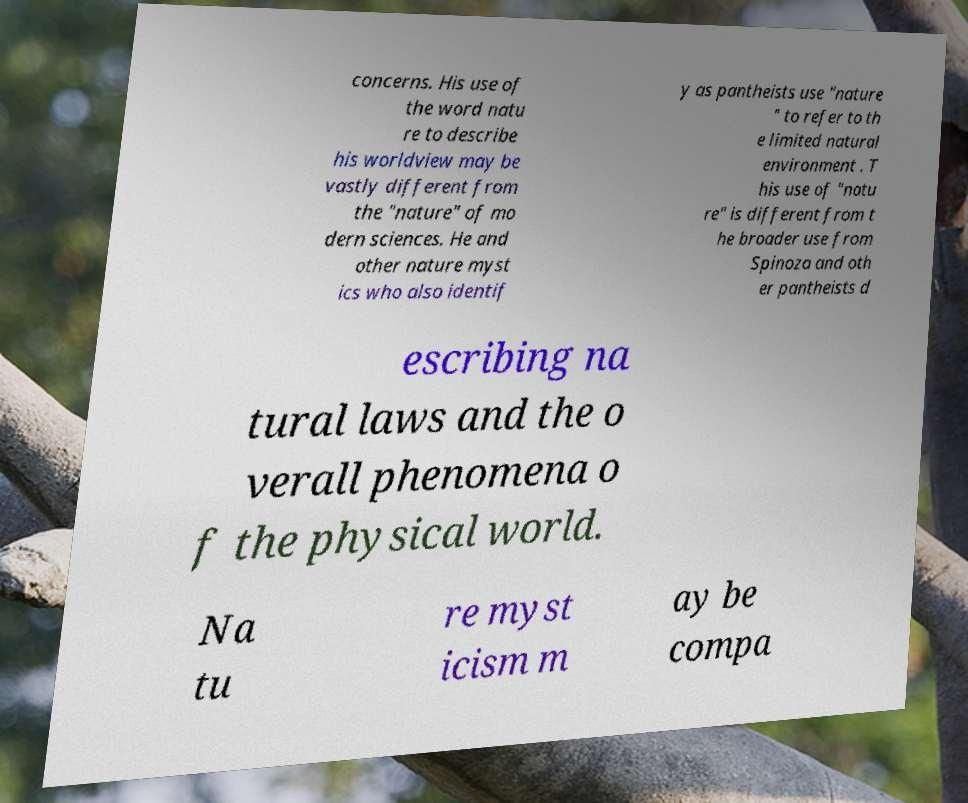Please read and relay the text visible in this image. What does it say? concerns. His use of the word natu re to describe his worldview may be vastly different from the "nature" of mo dern sciences. He and other nature myst ics who also identif y as pantheists use "nature " to refer to th e limited natural environment . T his use of "natu re" is different from t he broader use from Spinoza and oth er pantheists d escribing na tural laws and the o verall phenomena o f the physical world. Na tu re myst icism m ay be compa 